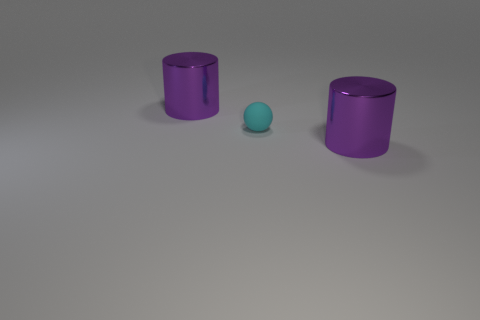Subtract all cylinders. How many objects are left? 1 Add 2 blue shiny spheres. How many objects exist? 5 Subtract 1 balls. How many balls are left? 0 Subtract all yellow balls. Subtract all purple cylinders. How many balls are left? 1 Subtract all purple spheres. How many gray cylinders are left? 0 Subtract all cyan matte spheres. Subtract all balls. How many objects are left? 1 Add 3 big metallic cylinders. How many big metallic cylinders are left? 5 Add 1 big gray shiny things. How many big gray shiny things exist? 1 Subtract 0 gray cubes. How many objects are left? 3 